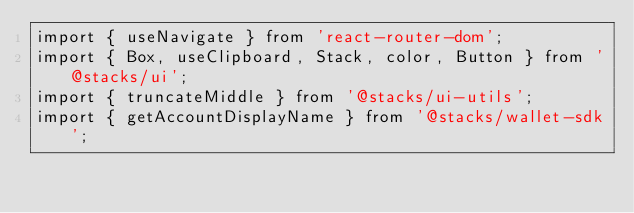<code> <loc_0><loc_0><loc_500><loc_500><_TypeScript_>import { useNavigate } from 'react-router-dom';
import { Box, useClipboard, Stack, color, Button } from '@stacks/ui';
import { truncateMiddle } from '@stacks/ui-utils';
import { getAccountDisplayName } from '@stacks/wallet-sdk';
</code> 